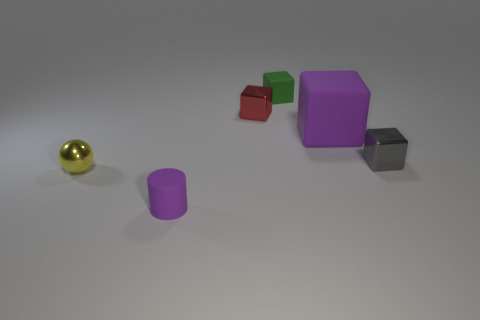Are there any other things that are the same size as the purple rubber block?
Provide a short and direct response. No. Is the cylinder the same size as the red metal block?
Give a very brief answer. Yes. The small matte object that is the same shape as the big purple rubber thing is what color?
Offer a terse response. Green. How many small objects have the same color as the large rubber object?
Provide a short and direct response. 1. Are there more rubber blocks that are to the right of the tiny green object than yellow metallic cylinders?
Your answer should be compact. Yes. The metal block that is in front of the matte object on the right side of the green object is what color?
Your answer should be very brief. Gray. What number of things are either purple matte objects that are to the right of the small cylinder or objects that are behind the red shiny cube?
Your answer should be very brief. 2. The tiny shiny ball has what color?
Your answer should be very brief. Yellow. How many purple cylinders have the same material as the small green object?
Provide a short and direct response. 1. Is the number of gray cubes greater than the number of tiny objects?
Ensure brevity in your answer.  No. 